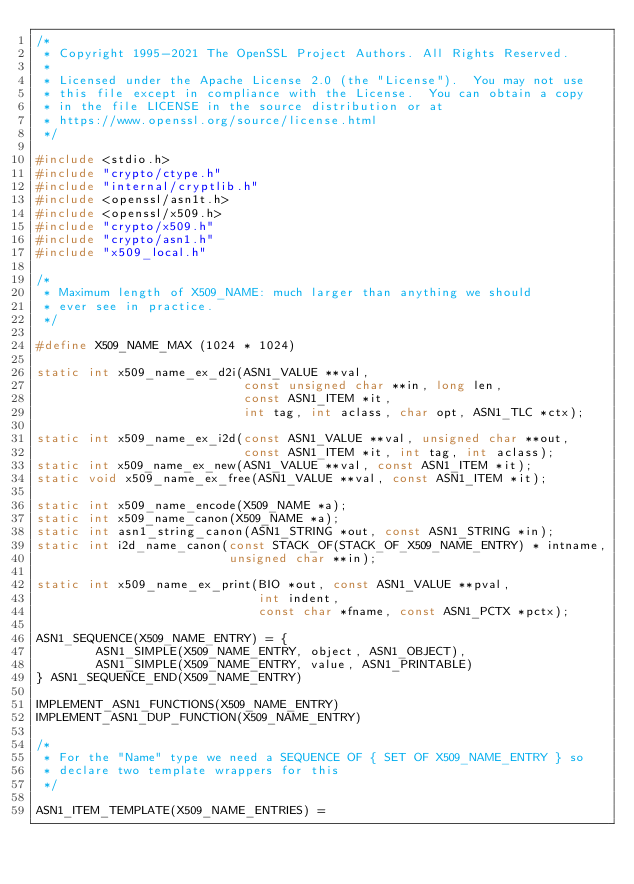<code> <loc_0><loc_0><loc_500><loc_500><_C_>/*
 * Copyright 1995-2021 The OpenSSL Project Authors. All Rights Reserved.
 *
 * Licensed under the Apache License 2.0 (the "License").  You may not use
 * this file except in compliance with the License.  You can obtain a copy
 * in the file LICENSE in the source distribution or at
 * https://www.openssl.org/source/license.html
 */

#include <stdio.h>
#include "crypto/ctype.h"
#include "internal/cryptlib.h"
#include <openssl/asn1t.h>
#include <openssl/x509.h>
#include "crypto/x509.h"
#include "crypto/asn1.h"
#include "x509_local.h"

/*
 * Maximum length of X509_NAME: much larger than anything we should
 * ever see in practice.
 */

#define X509_NAME_MAX (1024 * 1024)

static int x509_name_ex_d2i(ASN1_VALUE **val,
                            const unsigned char **in, long len,
                            const ASN1_ITEM *it,
                            int tag, int aclass, char opt, ASN1_TLC *ctx);

static int x509_name_ex_i2d(const ASN1_VALUE **val, unsigned char **out,
                            const ASN1_ITEM *it, int tag, int aclass);
static int x509_name_ex_new(ASN1_VALUE **val, const ASN1_ITEM *it);
static void x509_name_ex_free(ASN1_VALUE **val, const ASN1_ITEM *it);

static int x509_name_encode(X509_NAME *a);
static int x509_name_canon(X509_NAME *a);
static int asn1_string_canon(ASN1_STRING *out, const ASN1_STRING *in);
static int i2d_name_canon(const STACK_OF(STACK_OF_X509_NAME_ENTRY) * intname,
                          unsigned char **in);

static int x509_name_ex_print(BIO *out, const ASN1_VALUE **pval,
                              int indent,
                              const char *fname, const ASN1_PCTX *pctx);

ASN1_SEQUENCE(X509_NAME_ENTRY) = {
        ASN1_SIMPLE(X509_NAME_ENTRY, object, ASN1_OBJECT),
        ASN1_SIMPLE(X509_NAME_ENTRY, value, ASN1_PRINTABLE)
} ASN1_SEQUENCE_END(X509_NAME_ENTRY)

IMPLEMENT_ASN1_FUNCTIONS(X509_NAME_ENTRY)
IMPLEMENT_ASN1_DUP_FUNCTION(X509_NAME_ENTRY)

/*
 * For the "Name" type we need a SEQUENCE OF { SET OF X509_NAME_ENTRY } so
 * declare two template wrappers for this
 */

ASN1_ITEM_TEMPLATE(X509_NAME_ENTRIES) =</code> 